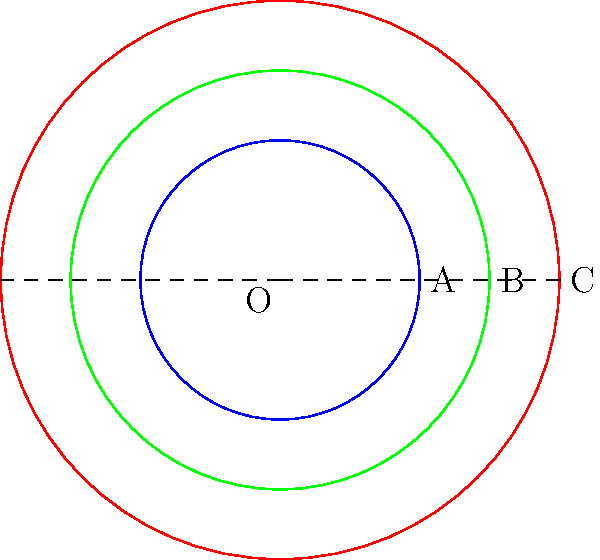The circular diagrams represent the blast radii of three different explosive ordnance types: A, B, and C. If the area affected by ordnance A is 400 square meters, calculate the areas affected by ordnance B and C. What is the total affected area of all three ordnance types combined? Let's approach this step-by-step:

1) Given: Area of A = 400 m²

2) The area of a circle is given by the formula $A = \pi r^2$

3) For ordnance A:
   $400 = \pi r_A^2$
   $r_A^2 = \frac{400}{\pi}$
   $r_A = \sqrt{\frac{400}{\pi}} \approx 11.28$ m

4) From the diagram, we can see that:
   $r_B = 1.5r_A$ and $r_C = 2r_A$

5) For ordnance B:
   $r_B = 1.5 * 11.28 = 16.92$ m
   $A_B = \pi r_B^2 = \pi * 16.92^2 \approx 900$ m²

6) For ordnance C:
   $r_C = 2 * 11.28 = 22.56$ m
   $A_C = \pi r_C^2 = \pi * 22.56^2 \approx 1600$ m²

7) Total affected area:
   $A_{total} = A_A + A_B + A_C = 400 + 900 + 1600 = 2900$ m²
Answer: 2900 m² 